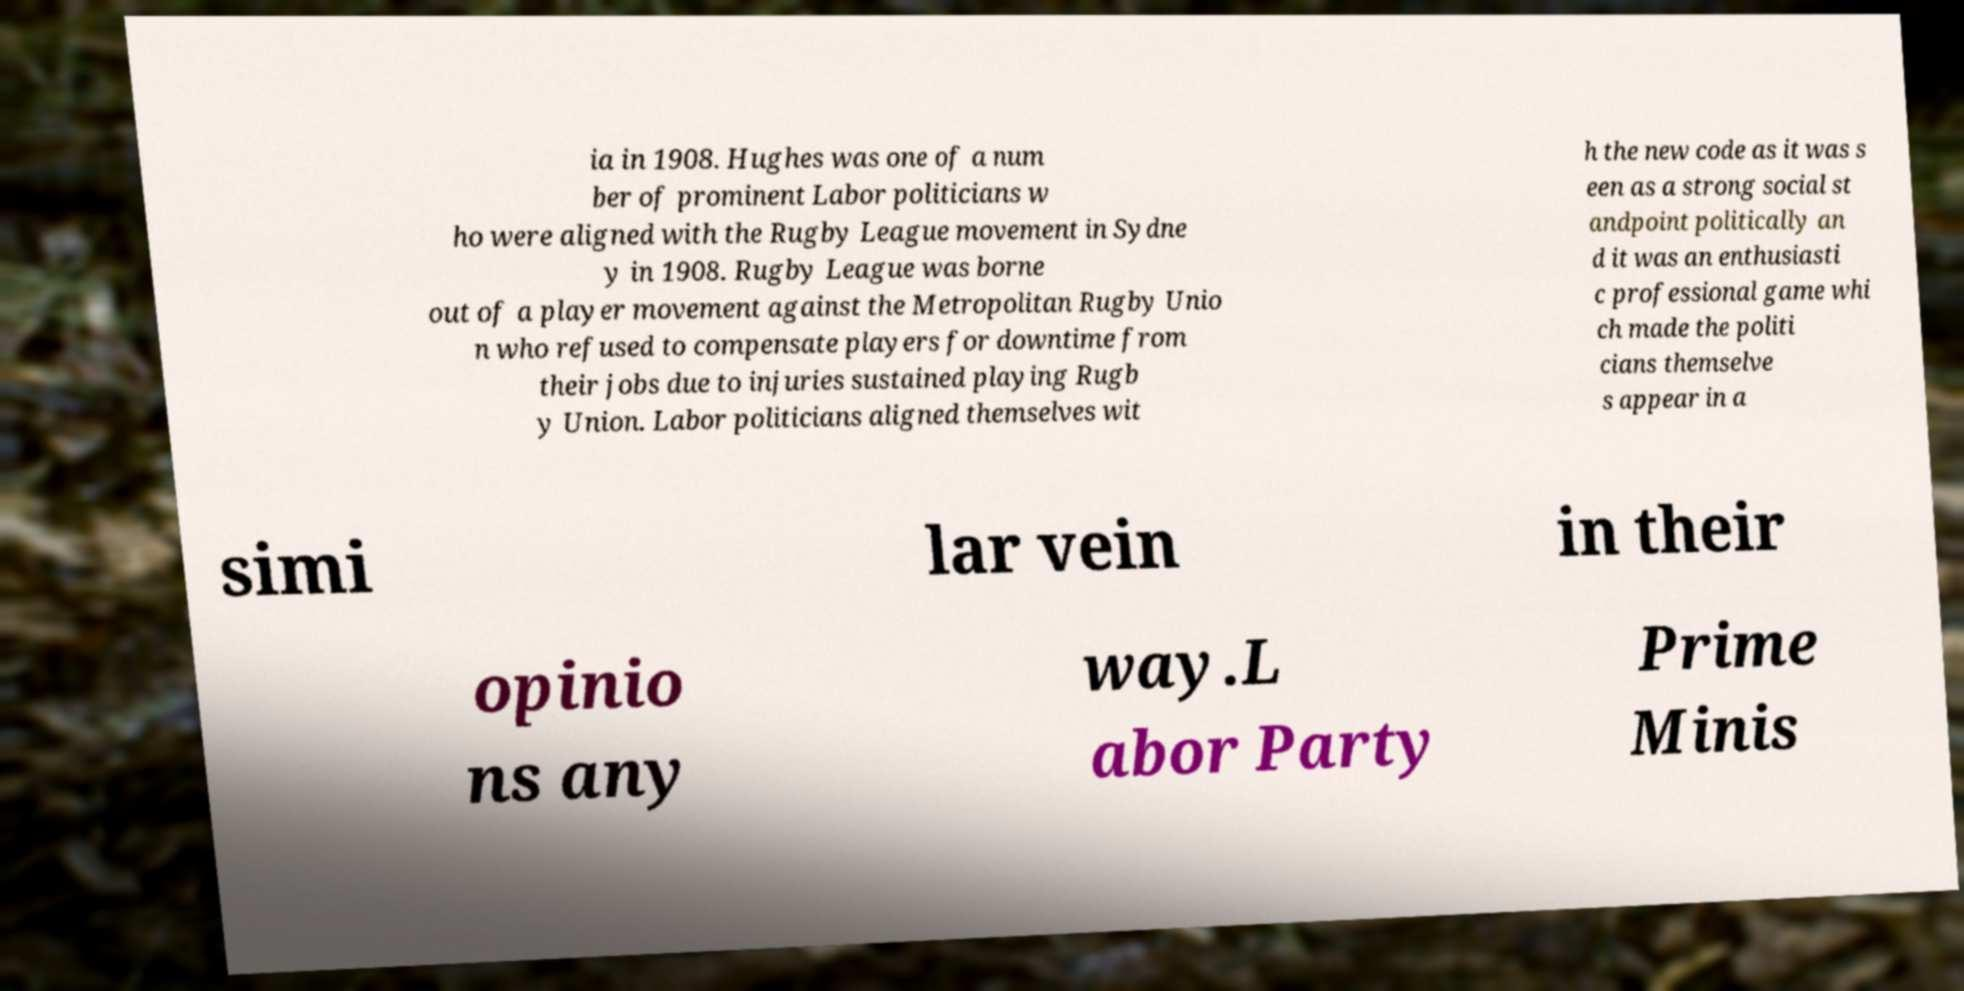I need the written content from this picture converted into text. Can you do that? ia in 1908. Hughes was one of a num ber of prominent Labor politicians w ho were aligned with the Rugby League movement in Sydne y in 1908. Rugby League was borne out of a player movement against the Metropolitan Rugby Unio n who refused to compensate players for downtime from their jobs due to injuries sustained playing Rugb y Union. Labor politicians aligned themselves wit h the new code as it was s een as a strong social st andpoint politically an d it was an enthusiasti c professional game whi ch made the politi cians themselve s appear in a simi lar vein in their opinio ns any way.L abor Party Prime Minis 